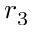<formula> <loc_0><loc_0><loc_500><loc_500>r _ { 3 }</formula> 